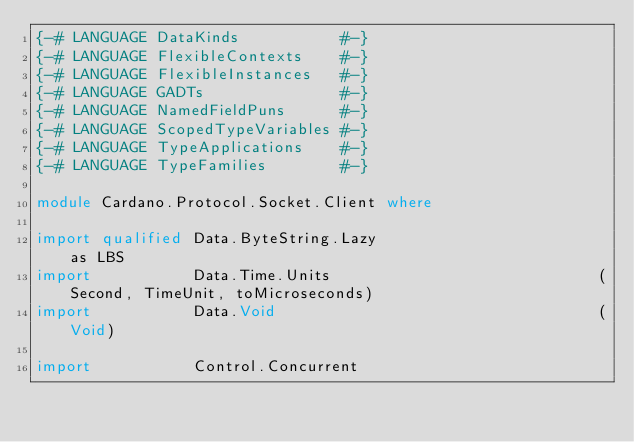Convert code to text. <code><loc_0><loc_0><loc_500><loc_500><_Haskell_>{-# LANGUAGE DataKinds           #-}
{-# LANGUAGE FlexibleContexts    #-}
{-# LANGUAGE FlexibleInstances   #-}
{-# LANGUAGE GADTs               #-}
{-# LANGUAGE NamedFieldPuns      #-}
{-# LANGUAGE ScopedTypeVariables #-}
{-# LANGUAGE TypeApplications    #-}
{-# LANGUAGE TypeFamilies        #-}

module Cardano.Protocol.Socket.Client where

import qualified Data.ByteString.Lazy                        as LBS
import           Data.Time.Units                             (Second, TimeUnit, toMicroseconds)
import           Data.Void                                   (Void)

import           Control.Concurrent</code> 